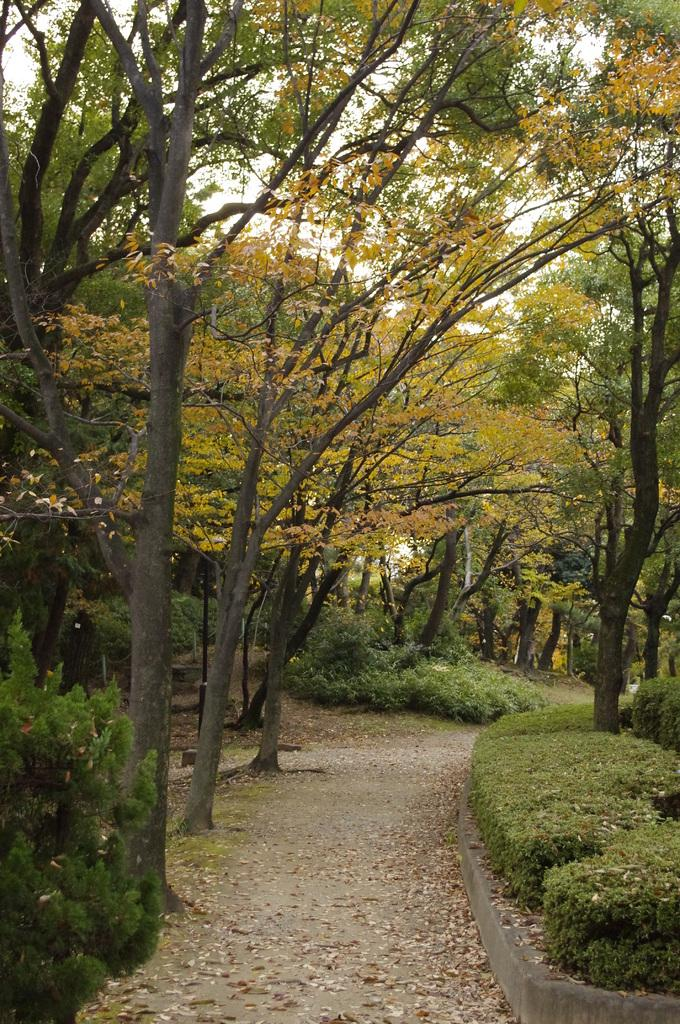What can be seen at the bottom of the image? Dry leaves are present at the bottom of the image. What type of vegetation is on the right side of the image? Shrubs are visible on the right side of the image. What else is present in the image besides the shrubs? Trees are present in the image. What can be seen in the background of the image? There are trees in the background of the image. Where might this image have been taken? The image might have been taken in a park. What type of muscle can be seen flexing in the image? There is no muscle present in the image; it features dry leaves, shrubs, and trees. What season is depicted in the image? The provided facts do not mention any specific season, so it cannot be determined from the image. 